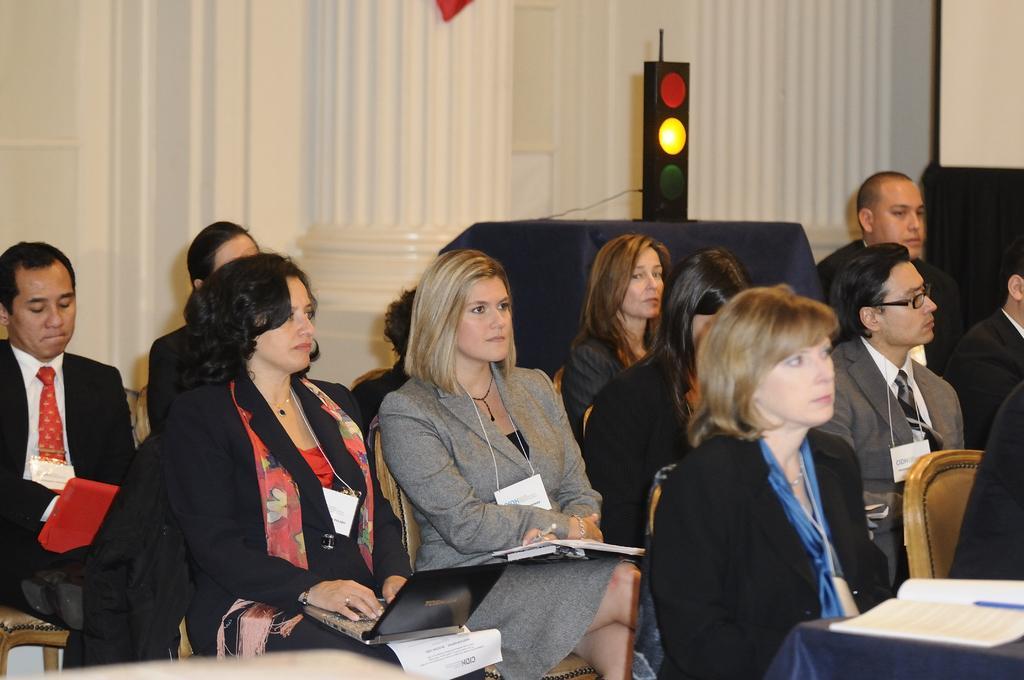How would you summarize this image in a sentence or two? In this image, there are a few people sitting. We can see some tables covered with a cloth and some objects are placed on them. We can also see a traffic light, a pillar. We can see the wall and an object at the right. 